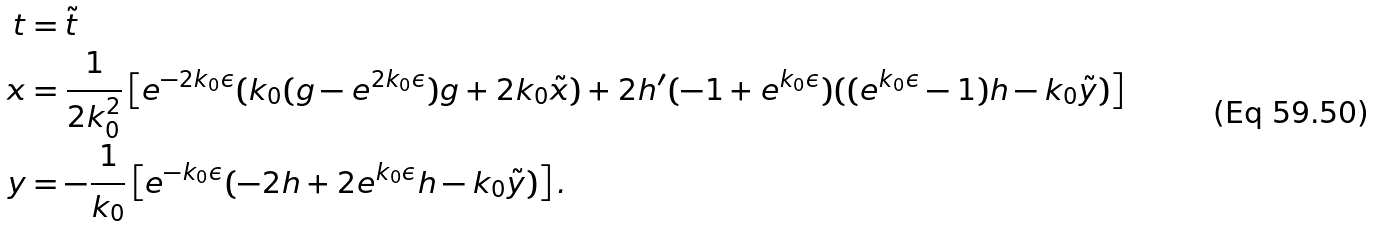<formula> <loc_0><loc_0><loc_500><loc_500>t & = \tilde { t } \\ x & = \frac { 1 } { 2 k _ { 0 } ^ { 2 } } \left [ e ^ { - 2 k _ { 0 } \epsilon } ( k _ { 0 } ( g - e ^ { 2 k _ { 0 } \epsilon } ) g + 2 k _ { 0 } \tilde { x } ) + 2 h ^ { \prime } ( - 1 + e ^ { k _ { 0 } \epsilon } ) ( ( e ^ { k _ { 0 } \epsilon } - 1 ) h - k _ { 0 } \tilde { y } ) \right ] \\ y & = - \frac { 1 } { k _ { 0 } } \left [ e ^ { - k _ { 0 } \epsilon } ( - 2 h + 2 e ^ { k _ { 0 } \epsilon } h - k _ { 0 } \tilde { y } ) \right ] . \\</formula> 